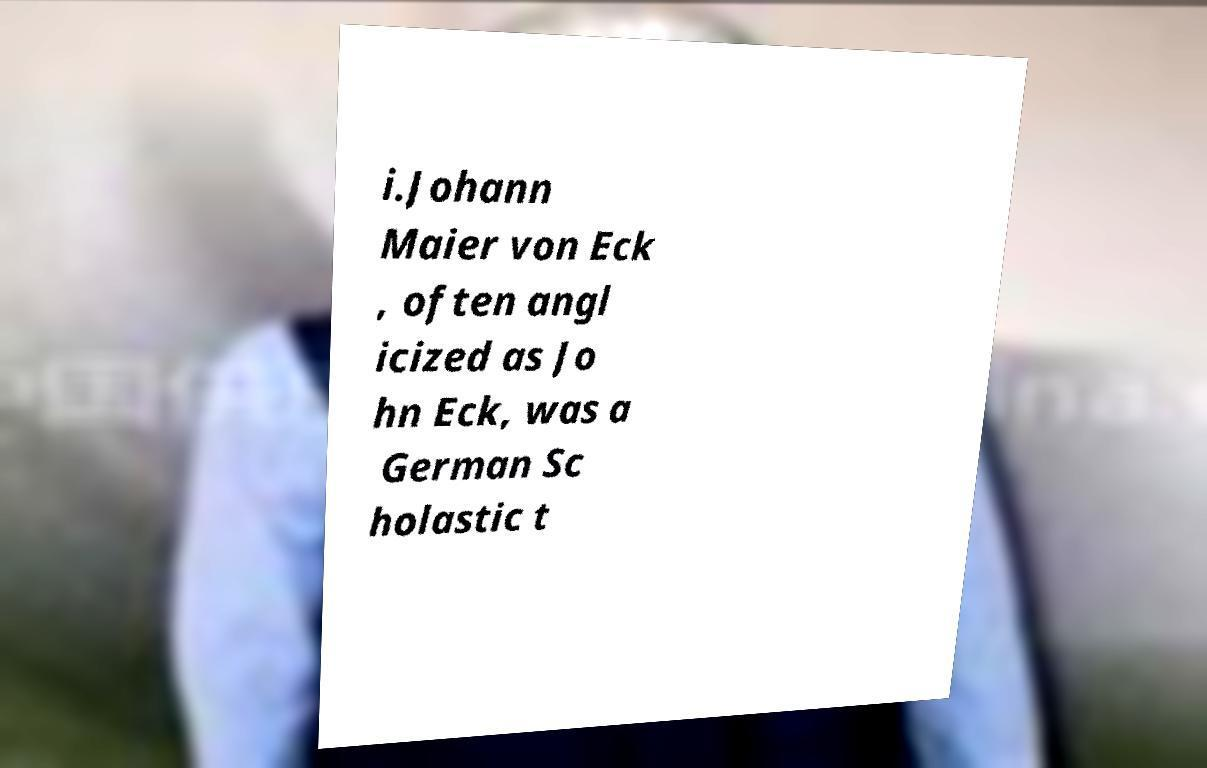There's text embedded in this image that I need extracted. Can you transcribe it verbatim? i.Johann Maier von Eck , often angl icized as Jo hn Eck, was a German Sc holastic t 